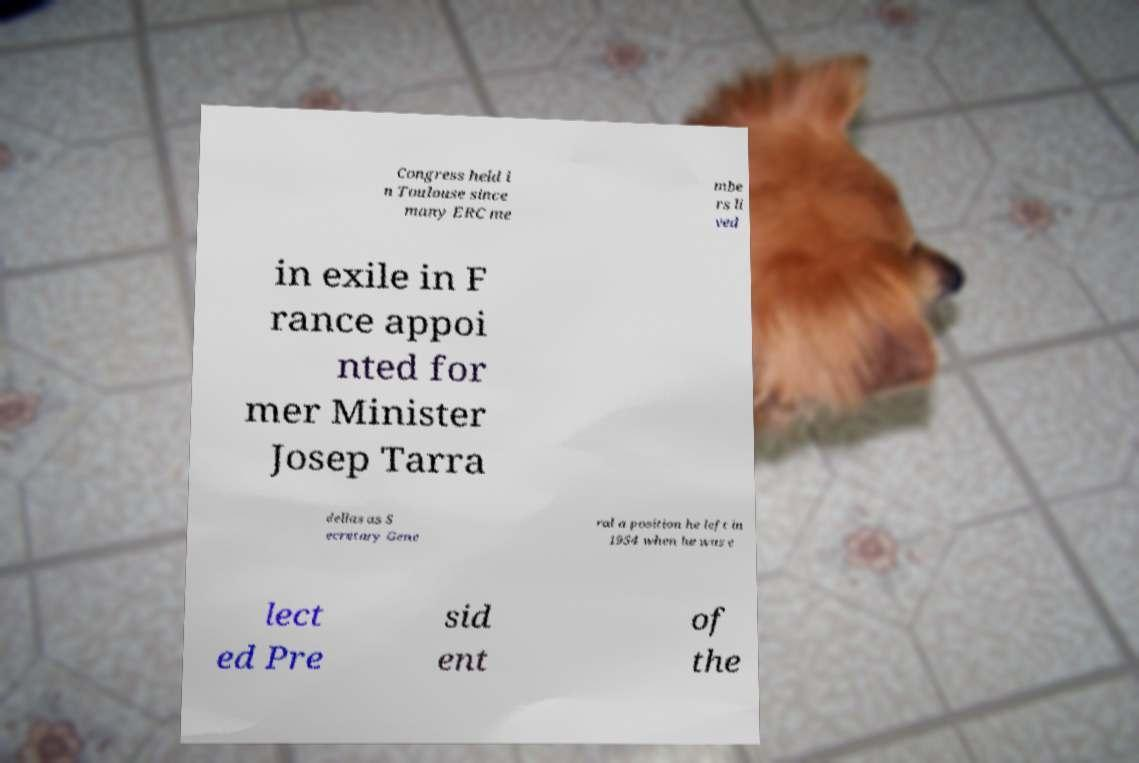Please identify and transcribe the text found in this image. Congress held i n Toulouse since many ERC me mbe rs li ved in exile in F rance appoi nted for mer Minister Josep Tarra dellas as S ecretary Gene ral a position he left in 1954 when he was e lect ed Pre sid ent of the 